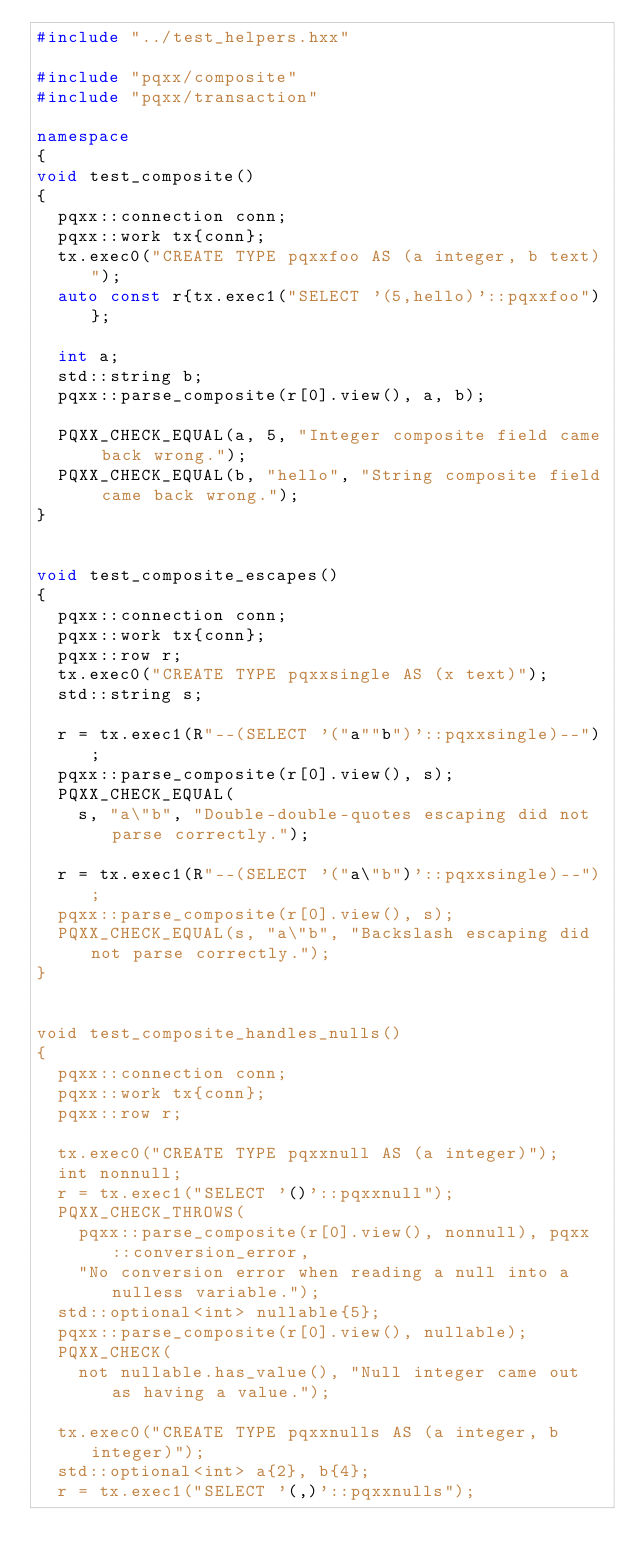Convert code to text. <code><loc_0><loc_0><loc_500><loc_500><_C++_>#include "../test_helpers.hxx"

#include "pqxx/composite"
#include "pqxx/transaction"

namespace
{
void test_composite()
{
  pqxx::connection conn;
  pqxx::work tx{conn};
  tx.exec0("CREATE TYPE pqxxfoo AS (a integer, b text)");
  auto const r{tx.exec1("SELECT '(5,hello)'::pqxxfoo")};

  int a;
  std::string b;
  pqxx::parse_composite(r[0].view(), a, b);

  PQXX_CHECK_EQUAL(a, 5, "Integer composite field came back wrong.");
  PQXX_CHECK_EQUAL(b, "hello", "String composite field came back wrong.");
}


void test_composite_escapes()
{
  pqxx::connection conn;
  pqxx::work tx{conn};
  pqxx::row r;
  tx.exec0("CREATE TYPE pqxxsingle AS (x text)");
  std::string s;

  r = tx.exec1(R"--(SELECT '("a""b")'::pqxxsingle)--");
  pqxx::parse_composite(r[0].view(), s);
  PQXX_CHECK_EQUAL(
    s, "a\"b", "Double-double-quotes escaping did not parse correctly.");

  r = tx.exec1(R"--(SELECT '("a\"b")'::pqxxsingle)--");
  pqxx::parse_composite(r[0].view(), s);
  PQXX_CHECK_EQUAL(s, "a\"b", "Backslash escaping did not parse correctly.");
}


void test_composite_handles_nulls()
{
  pqxx::connection conn;
  pqxx::work tx{conn};
  pqxx::row r;

  tx.exec0("CREATE TYPE pqxxnull AS (a integer)");
  int nonnull;
  r = tx.exec1("SELECT '()'::pqxxnull");
  PQXX_CHECK_THROWS(
    pqxx::parse_composite(r[0].view(), nonnull), pqxx::conversion_error,
    "No conversion error when reading a null into a nulless variable.");
  std::optional<int> nullable{5};
  pqxx::parse_composite(r[0].view(), nullable);
  PQXX_CHECK(
    not nullable.has_value(), "Null integer came out as having a value.");

  tx.exec0("CREATE TYPE pqxxnulls AS (a integer, b integer)");
  std::optional<int> a{2}, b{4};
  r = tx.exec1("SELECT '(,)'::pqxxnulls");</code> 